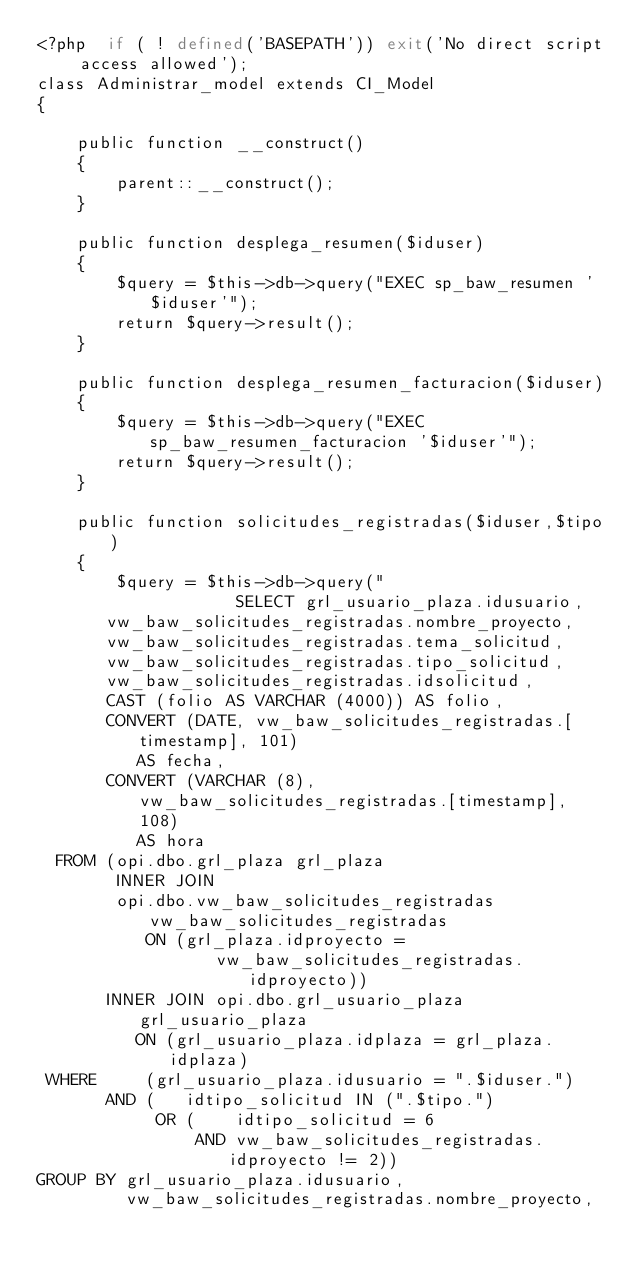<code> <loc_0><loc_0><loc_500><loc_500><_PHP_><?php  if ( ! defined('BASEPATH')) exit('No direct script access allowed');
class Administrar_model extends CI_Model
{

    public function __construct()
    {
        parent::__construct();
    }

	public function desplega_resumen($iduser)
	{
		$query = $this->db->query("EXEC sp_baw_resumen '$iduser'");
        return $query->result();
	}

	public function desplega_resumen_facturacion($iduser)
	{
		$query = $this->db->query("EXEC sp_baw_resumen_facturacion '$iduser'");
        return $query->result();
	}

	public function solicitudes_registradas($iduser,$tipo)
	{
		$query = $this->db->query("
                    SELECT grl_usuario_plaza.idusuario,
       vw_baw_solicitudes_registradas.nombre_proyecto,
       vw_baw_solicitudes_registradas.tema_solicitud,
       vw_baw_solicitudes_registradas.tipo_solicitud,
       vw_baw_solicitudes_registradas.idsolicitud,
       CAST (folio AS VARCHAR (4000)) AS folio,
       CONVERT (DATE, vw_baw_solicitudes_registradas.[timestamp], 101)
          AS fecha,
       CONVERT (VARCHAR (8), vw_baw_solicitudes_registradas.[timestamp], 108)
          AS hora
  FROM (opi.dbo.grl_plaza grl_plaza
        INNER JOIN
        opi.dbo.vw_baw_solicitudes_registradas vw_baw_solicitudes_registradas
           ON (grl_plaza.idproyecto =
                  vw_baw_solicitudes_registradas.idproyecto))
       INNER JOIN opi.dbo.grl_usuario_plaza grl_usuario_plaza
          ON (grl_usuario_plaza.idplaza = grl_plaza.idplaza)
 WHERE     (grl_usuario_plaza.idusuario = ".$iduser.")
       AND (   idtipo_solicitud IN (".$tipo.")
            OR (    idtipo_solicitud = 6
                AND vw_baw_solicitudes_registradas.idproyecto != 2))
GROUP BY grl_usuario_plaza.idusuario,
         vw_baw_solicitudes_registradas.nombre_proyecto,</code> 